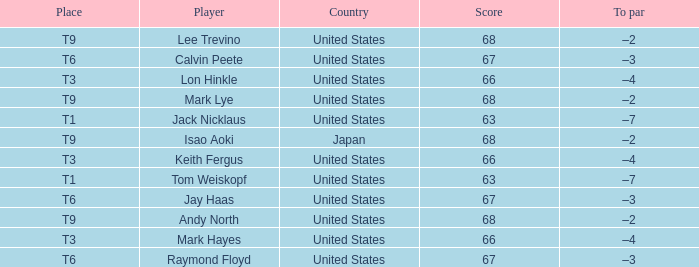What is the location, when the nation is "united states", and when the athlete is "lee trevino"? T9. 